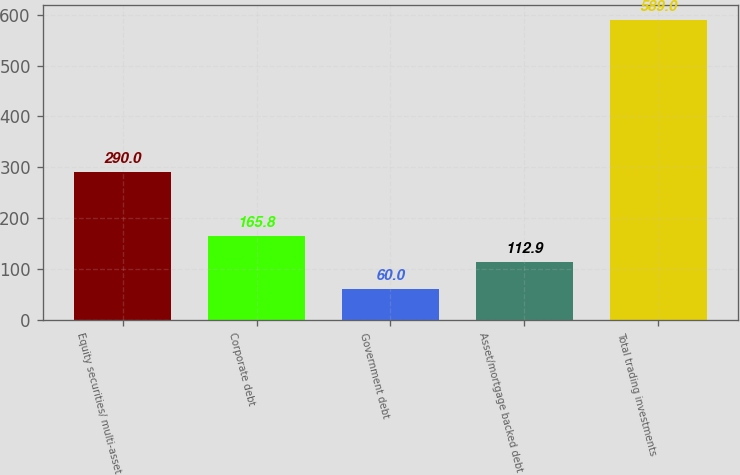<chart> <loc_0><loc_0><loc_500><loc_500><bar_chart><fcel>Equity securities/ multi-asset<fcel>Corporate debt<fcel>Government debt<fcel>Asset/mortgage backed debt<fcel>Total trading investments<nl><fcel>290<fcel>165.8<fcel>60<fcel>112.9<fcel>589<nl></chart> 